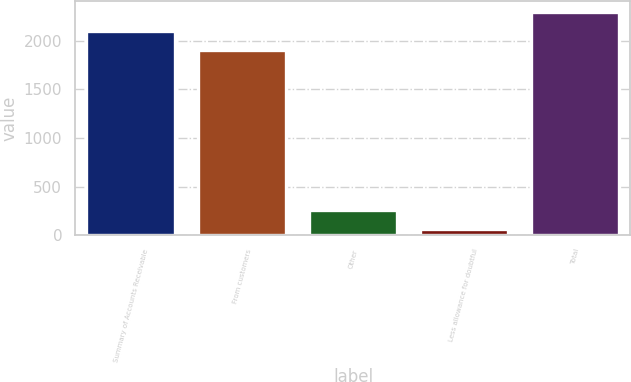Convert chart to OTSL. <chart><loc_0><loc_0><loc_500><loc_500><bar_chart><fcel>Summary of Accounts Receivable<fcel>From customers<fcel>Other<fcel>Less allowance for doubtful<fcel>Total<nl><fcel>2102.97<fcel>1905.4<fcel>260.17<fcel>62.6<fcel>2300.54<nl></chart> 